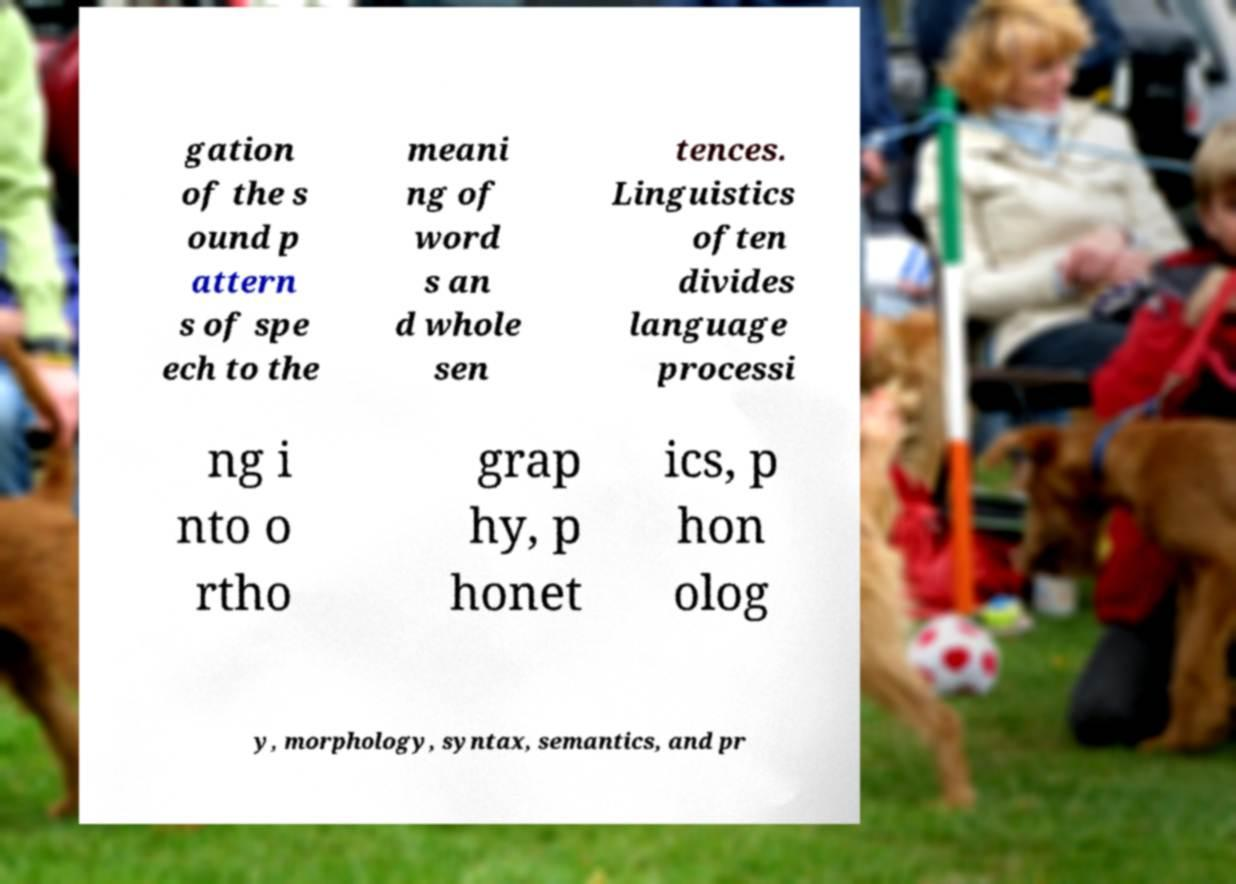Could you extract and type out the text from this image? gation of the s ound p attern s of spe ech to the meani ng of word s an d whole sen tences. Linguistics often divides language processi ng i nto o rtho grap hy, p honet ics, p hon olog y, morphology, syntax, semantics, and pr 